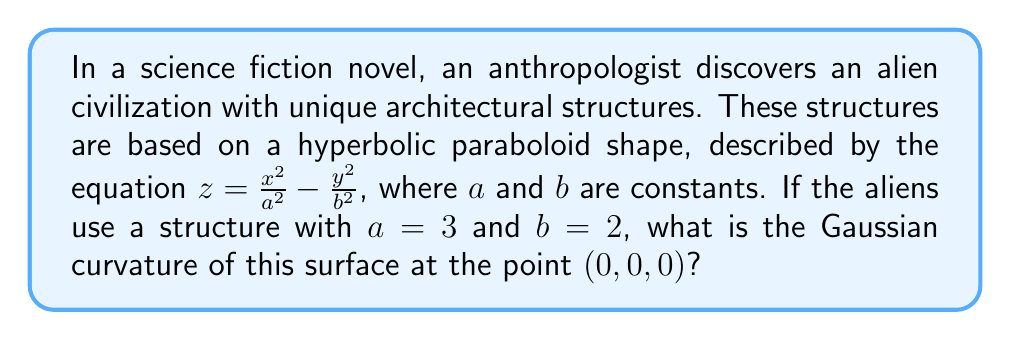Provide a solution to this math problem. To solve this problem, we'll follow these steps:

1) The Gaussian curvature $K$ of a surface $z = f(x,y)$ at a point $(x,y,z)$ is given by:

   $$K = \frac{f_{xx}f_{yy} - f_{xy}^2}{(1 + f_x^2 + f_y^2)^2}$$

   where $f_x$, $f_y$, $f_{xx}$, $f_{yy}$, and $f_{xy}$ are partial derivatives.

2) For our hyperbolic paraboloid $z = \frac{x^2}{a^2} - \frac{y^2}{b^2}$, let's calculate these derivatives:

   $f_x = \frac{2x}{a^2}$
   $f_y = -\frac{2y}{b^2}$
   $f_{xx} = \frac{2}{a^2}$
   $f_{yy} = -\frac{2}{b^2}$
   $f_{xy} = 0$

3) At the point $(0,0,0)$, $f_x = f_y = 0$, so our formula simplifies to:

   $$K = f_{xx}f_{yy} - f_{xy}^2$$

4) Substituting the values:

   $$K = (\frac{2}{a^2})(-\frac{2}{b^2}) - 0^2$$

5) Now, let's plug in $a = 3$ and $b = 2$:

   $$K = (\frac{2}{3^2})(-\frac{2}{2^2}) = (\frac{2}{9})(-\frac{1}{2}) = -\frac{1}{9}$$

Therefore, the Gaussian curvature at the point $(0,0,0)$ is $-\frac{1}{9}$.
Answer: $-\frac{1}{9}$ 